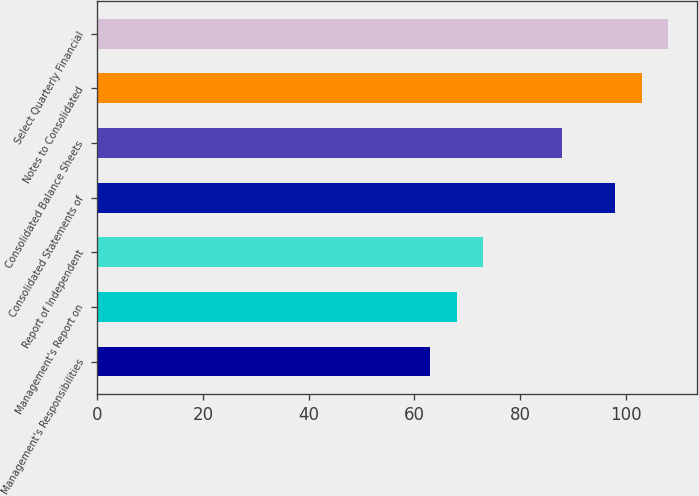Convert chart to OTSL. <chart><loc_0><loc_0><loc_500><loc_500><bar_chart><fcel>Management's Responsibilities<fcel>Management's Report on<fcel>Report of Independent<fcel>Consolidated Statements of<fcel>Consolidated Balance Sheets<fcel>Notes to Consolidated<fcel>Select Quarterly Financial<nl><fcel>63<fcel>68<fcel>73<fcel>98<fcel>88<fcel>103<fcel>108<nl></chart> 